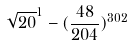Convert formula to latex. <formula><loc_0><loc_0><loc_500><loc_500>\sqrt { 2 0 } ^ { 1 } - ( \frac { 4 8 } { 2 0 4 } ) ^ { 3 0 2 }</formula> 